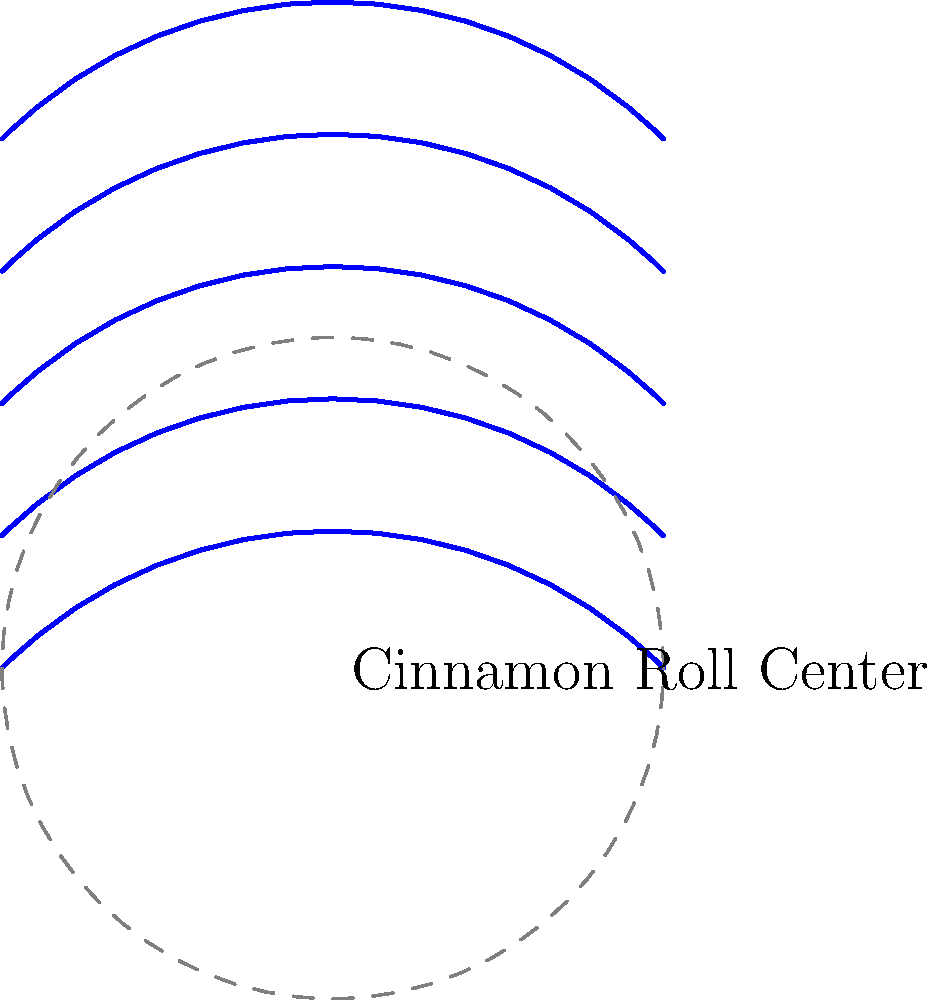As a food blogger with a keen eye for pastry aesthetics, you notice that the swirls in a freshly baked cinnamon roll resemble parallel lines in hyperbolic geometry. If these swirls were to continue infinitely, how would they behave in relation to each other within the hyperbolic plane? To understand the behavior of parallel lines in hyperbolic geometry as represented by cinnamon roll swirls, let's break it down:

1. In Euclidean geometry, parallel lines maintain a constant distance from each other and never intersect.

2. However, in hyperbolic geometry, the concept of parallelism is different:
   a) Parallel lines in hyperbolic geometry appear to "bend away" from each other.
   b) They maintain the property of never intersecting, even when extended infinitely.

3. In the cinnamon roll analogy:
   a) Each swirl represents a line in hyperbolic geometry.
   b) As you move outward from the center of the roll, the swirls (lines) appear to curve and spread apart more rapidly.

4. Key properties of these hyperbolic parallel lines:
   a) They diverge exponentially as you move away from a reference point (the center of the roll).
   b) The distance between any two adjacent swirls increases as you move outward.
   c) Despite this divergence, the lines never actually intersect.

5. In the hyperbolic plane model:
   a) The entire infinite hyperbolic plane is represented within a finite circle (like the outer edge of the cinnamon roll).
   b) Points on the circle's circumference represent "points at infinity" in the hyperbolic plane.

6. As the swirls approach the edge of the roll (representing infinity in the hyperbolic plane), they appear to become perpendicular to the boundary.

Therefore, the cinnamon roll swirls, representing parallel lines in hyperbolic geometry, would continue to diverge from each other at an exponential rate as they extend outward, never intersecting but approaching perpendicularity to the boundary at infinity.
Answer: Diverge exponentially without intersecting 